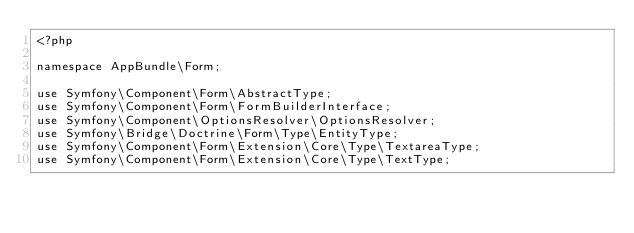<code> <loc_0><loc_0><loc_500><loc_500><_PHP_><?php

namespace AppBundle\Form;

use Symfony\Component\Form\AbstractType;
use Symfony\Component\Form\FormBuilderInterface;
use Symfony\Component\OptionsResolver\OptionsResolver;
use Symfony\Bridge\Doctrine\Form\Type\EntityType;
use Symfony\Component\Form\Extension\Core\Type\TextareaType;
use Symfony\Component\Form\Extension\Core\Type\TextType;</code> 